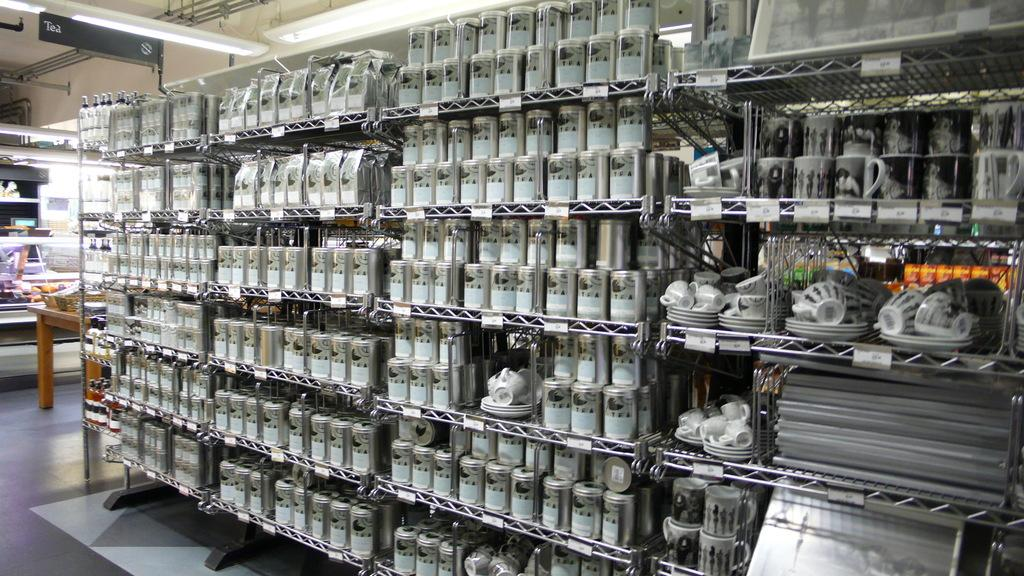What type of containers are in the metal racks in the image? There are cups in the metal racks in the image. What other items are visible in the image besides the cups? There are cups and saucers in the image. What type of furniture is present in the image? There is a wooden table in the image. What can be seen illuminating the area in the image? There are lights visible in the image. What is located on the roof in the image? There is a name board on the roof. What type of shock can be seen on the wooden table in the image? There is no shock visible on the wooden table in the image. 